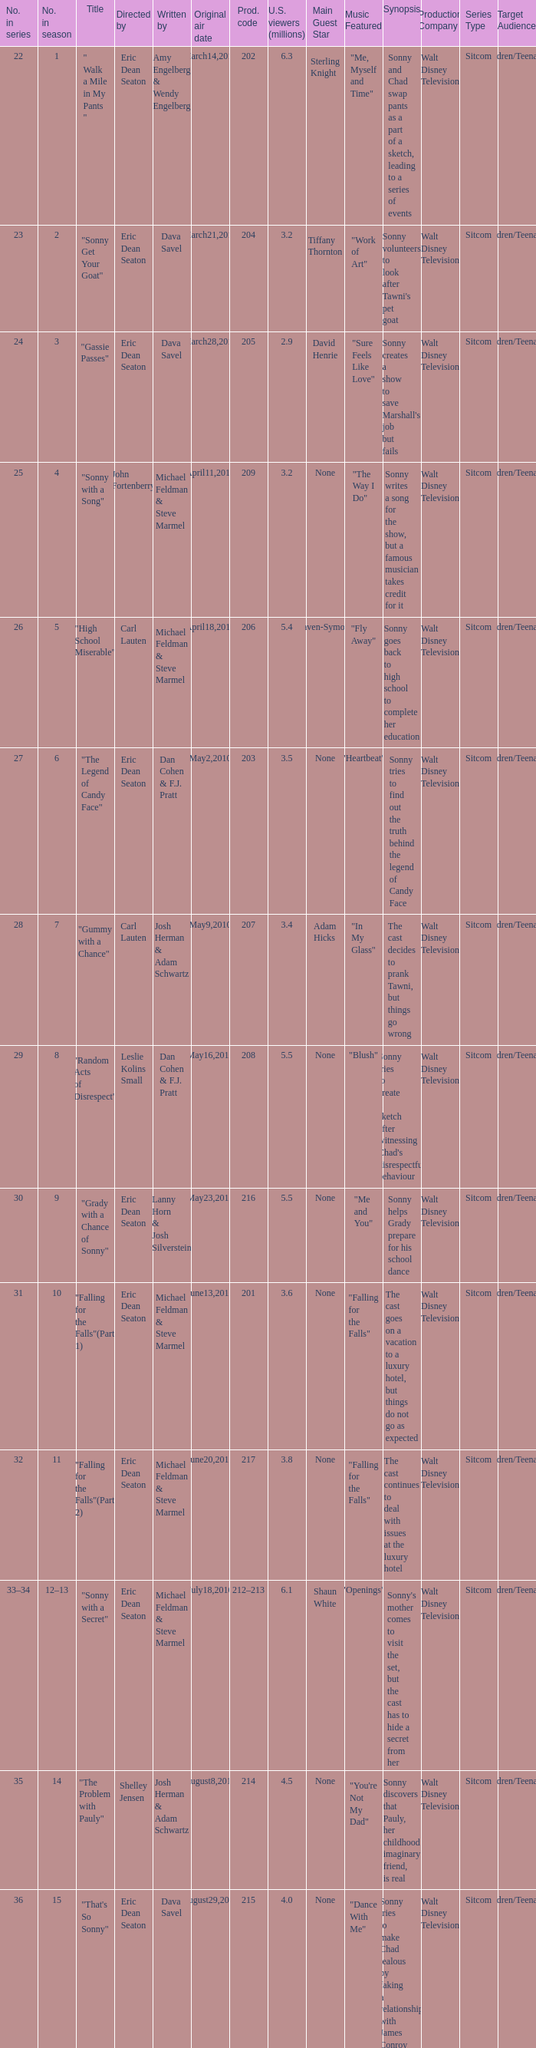How man episodes in the season were titled "that's so sonny"? 1.0. Could you help me parse every detail presented in this table? {'header': ['No. in series', 'No. in season', 'Title', 'Directed by', 'Written by', 'Original air date', 'Prod. code', 'U.S. viewers (millions)', 'Main Guest Star', 'Music Featured', 'Synopsis', 'Production Company', 'Series Type', 'Target Audience'], 'rows': [['22', '1', '" Walk a Mile in My Pants "', 'Eric Dean Seaton', 'Amy Engelberg & Wendy Engelberg', 'March14,2010', '202', '6.3', 'Sterling Knight', '"Me, Myself and Time"', 'Sonny and Chad swap pants as a part of a sketch, leading to a series of events', 'Walt Disney Television', 'Sitcom', 'Children/Teenagers'], ['23', '2', '"Sonny Get Your Goat"', 'Eric Dean Seaton', 'Dava Savel', 'March21,2010', '204', '3.2', 'Tiffany Thornton', '"Work of Art"', "Sonny volunteers to look after Tawni's pet goat", 'Walt Disney Television', 'Sitcom', 'Children/Teenagers'], ['24', '3', '"Gassie Passes"', 'Eric Dean Seaton', 'Dava Savel', 'March28,2010', '205', '2.9', 'David Henrie', '"Sure Feels Like Love"', "Sonny creates a show to save Marshall's job but fails", 'Walt Disney Television', 'Sitcom', 'Children/Teenagers'], ['25', '4', '"Sonny with a Song"', 'John Fortenberry', 'Michael Feldman & Steve Marmel', 'April11,2010', '209', '3.2', 'None', '"The Way I Do"', 'Sonny writes a song for the show, but a famous musician takes credit for it', 'Walt Disney Television', 'Sitcom', 'Children/Teenagers'], ['26', '5', '"High School Miserable"', 'Carl Lauten', 'Michael Feldman & Steve Marmel', 'April18,2010', '206', '5.4', 'Raven-Symone', '"Fly Away"', 'Sonny goes back to high school to complete her education', 'Walt Disney Television', 'Sitcom', 'Children/Teenagers'], ['27', '6', '"The Legend of Candy Face"', 'Eric Dean Seaton', 'Dan Cohen & F.J. Pratt', 'May2,2010', '203', '3.5', 'None', '"Heartbeat"', 'Sonny tries to find out the truth behind the legend of Candy Face', 'Walt Disney Television', 'Sitcom', 'Children/Teenagers'], ['28', '7', '"Gummy with a Chance"', 'Carl Lauten', 'Josh Herman & Adam Schwartz', 'May9,2010', '207', '3.4', 'Adam Hicks', '"In My Glass"', 'The cast decides to prank Tawni, but things go wrong', 'Walt Disney Television', 'Sitcom', 'Children/Teenagers'], ['29', '8', '"Random Acts of Disrespect"', 'Leslie Kolins Small', 'Dan Cohen & F.J. Pratt', 'May16,2010', '208', '5.5', 'None', '"Blush"', "Sonny tries to create a sketch after witnessing Chad's disrespectful behaviour", 'Walt Disney Television', 'Sitcom', 'Children/Teenagers'], ['30', '9', '"Grady with a Chance of Sonny"', 'Eric Dean Seaton', 'Lanny Horn & Josh Silverstein', 'May23,2010', '216', '5.5', 'None', '"Me and You"', 'Sonny helps Grady prepare for his school dance', 'Walt Disney Television', 'Sitcom', 'Children/Teenagers'], ['31', '10', '"Falling for the Falls"(Part 1)', 'Eric Dean Seaton', 'Michael Feldman & Steve Marmel', 'June13,2010', '201', '3.6', 'None', '"Falling for the Falls"', 'The cast goes on a vacation to a luxury hotel, but things do not go as expected', 'Walt Disney Television', 'Sitcom', 'Children/Teenagers'], ['32', '11', '"Falling for the Falls"(Part 2)', 'Eric Dean Seaton', 'Michael Feldman & Steve Marmel', 'June20,2010', '217', '3.8', 'None', '"Falling for the Falls"', 'The cast continues to deal with issues at the luxury hotel', 'Walt Disney Television', 'Sitcom', 'Children/Teenagers'], ['33–34', '12–13', '"Sonny with a Secret"', 'Eric Dean Seaton', 'Michael Feldman & Steve Marmel', 'July18,2010', '212–213', '6.1', 'Shaun White', '"Openings"', "Sonny's mother comes to visit the set, but the cast has to hide a secret from her", 'Walt Disney Television', 'Sitcom', 'Children/Teenagers'], ['35', '14', '"The Problem with Pauly"', 'Shelley Jensen', 'Josh Herman & Adam Schwartz', 'August8,2010', '214', '4.5', 'None', '"You\'re Not My Dad"', 'Sonny discovers that Pauly, her childhood imaginary friend, is real', 'Walt Disney Television', 'Sitcom', 'Children/Teenagers'], ['36', '15', '"That\'s So Sonny"', 'Eric Dean Seaton', 'Dava Savel', 'August29,2010', '215', '4.0', 'None', '"Dance With Me"', 'Sonny tries to make Chad jealous by faking a relationship with James Conroy', 'Walt Disney Television', 'Sitcom', 'Children/Teenagers'], ['37', '16', '"Chad Without a Chance"', 'Eric Dean Seaton', 'Amy Engelberg & Wendy Engelberg', 'September19,2010', '210', '4.0', 'None', '"Brother Nature"', 'Sonny and the cast help Chad after he injures himself', 'Walt Disney Television', 'Sitcom', 'Children/Teenagers'], ['38', '17', '"My Two Chads"', 'Eric Dean Seaton', 'Dan Cohen & F.J. Pratt', 'September26,2010', '211', '4.0', 'None', '"Freak The Freak Out"', 'Chad brings his stunt double on set, causing problems with the cast', 'Walt Disney Television', 'Sitcom', 'Children/Teenagers'], ['39', '18', '"A So Random! Halloween Special"', 'Eric Dean Seaton', 'Josh Herman & Adam Schwartz', 'October17,2010', '226', '4.0', 'None', '"Monster"', 'The cast prepares for a Halloween themed episode of the show', 'Walt Disney Television', 'Sitcom', 'Children/Teenagers'], ['40', '19', '"Sonny with a 100% Chance of Meddling"', 'Ron Mosely', 'Lanny Horn & Josh Silverstein', 'October24,2010', '219', '4.7', 'Debby Ryan', '"Gray Horizon"', "Sonny tries to meddle in Tawni's and Chad's personal lives", 'Walt Disney Television', 'Sitcom', 'Children/Teenagers'], ['41', '20', '"Dakota\'s Revenge"', 'Eric Dean Seaton', 'Dava Savel', 'November14,2010', '223', '3.7', 'None', '"Goodnight"', 'Dakota returns to the show seeking revenge, causing chaos on set', 'Walt Disney Television', 'Sitcom', 'Children/Teenagers'], ['42', '21', '"Sonny with a Kiss"', 'Eric Dean Seaton', 'Ellen Byron & Lissa Kapstrom', 'November21,2010', '220', '3.6', 'None', '"Beautiful Love"', 'Sonny and Chad share their first kiss on air, but issues arise', 'Walt Disney Television', 'Sitcom', 'Children/Teenagers'], ['43', '22', '"A So Random! Holiday Special"', 'Eric Dean Seaton', 'Michael Feldman & Steve Marmel', 'November28,2010', '218', '3.8', 'None', '"Winter Wonderland"', 'The cast celebrates the holidays with sketches, music, and special guests', 'Walt Disney Television', 'Sitcom', 'Children/Teenagers'], ['44', '23', '"Sonny with a Grant"', 'Eric Dean Seaton', 'Michael Feldman & Steve Marmel', 'December5,2010', '221', '4.0', 'None', '"Only in My Dreams"', 'Sonny must create a show to impress a grant committee', 'Walt Disney Television', 'Sitcom', 'Children/Teenagers'], ['45', '24', '"Marshall with a Chance"', 'Shannon Flynn', 'Carla Banks Waddles', 'December12,2010', '224', '3.2', 'None', '"Magic Mirror"', 'Marshall is given his own show, causing jealousy with the cast', 'Walt Disney Television', 'Sitcom', 'Children/Teenagers'], ['46', '25', '"Sonny with a Choice"', 'Eric Dean Seaton', 'Dan Cohen & F.J. Pratt', 'December19,2010', '222', '4.7', 'None', '"Love Goes On"', 'Sonny must choose between Chad and James Conroy', 'Walt Disney Television', 'Sitcom', 'Children/Teenagers']]} 